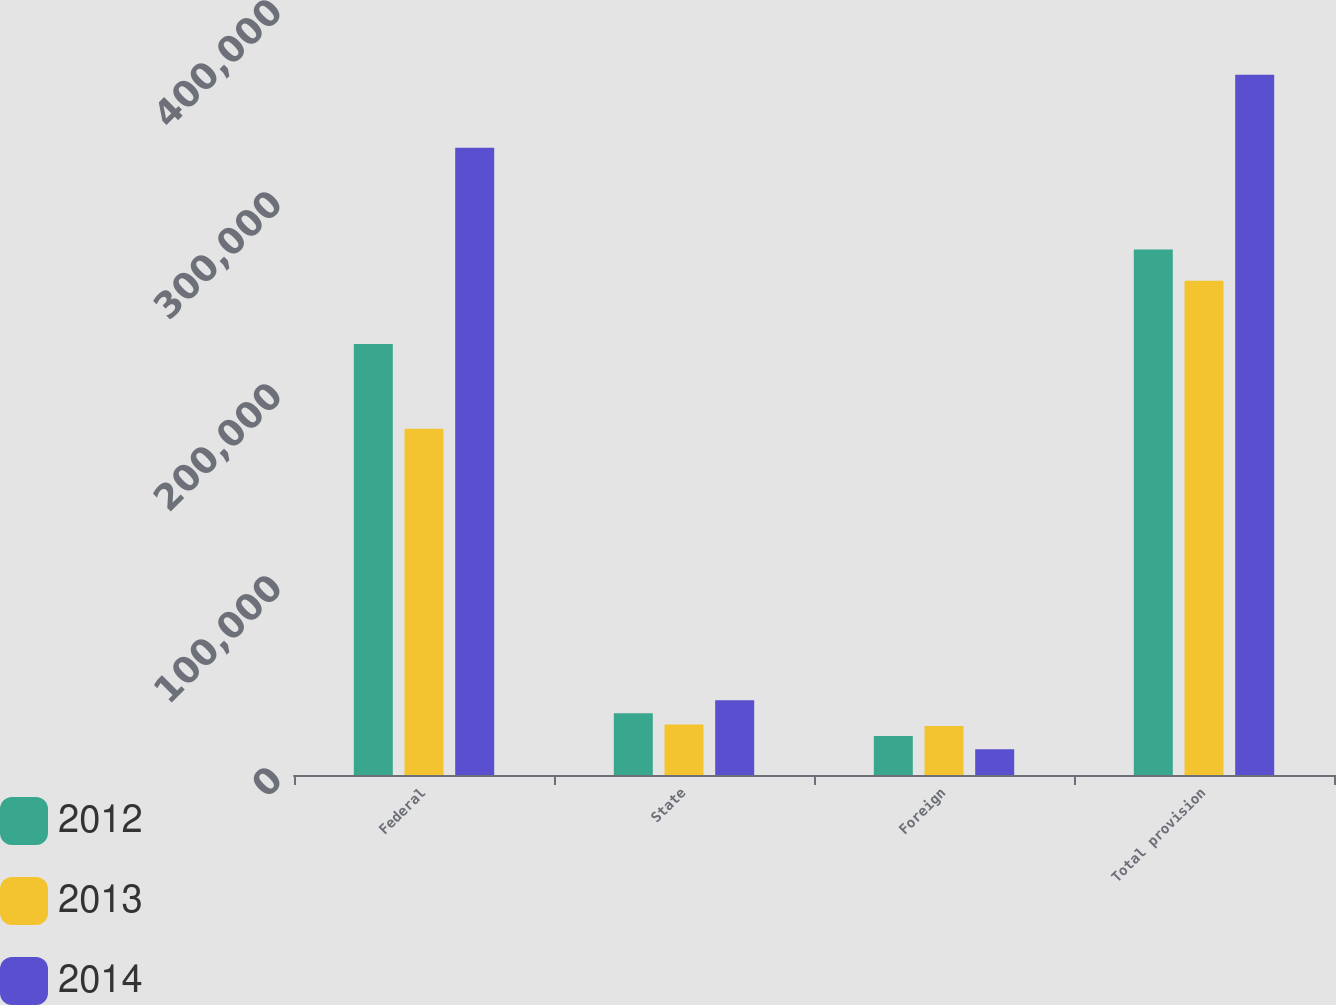Convert chart. <chart><loc_0><loc_0><loc_500><loc_500><stacked_bar_chart><ecel><fcel>Federal<fcel>State<fcel>Foreign<fcel>Total provision<nl><fcel>2012<fcel>224468<fcel>32110<fcel>20259<fcel>273720<nl><fcel>2013<fcel>180351<fcel>26351<fcel>25529<fcel>257457<nl><fcel>2014<fcel>326708<fcel>38931<fcel>13461<fcel>364658<nl></chart> 